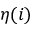Convert formula to latex. <formula><loc_0><loc_0><loc_500><loc_500>\eta ( i )</formula> 